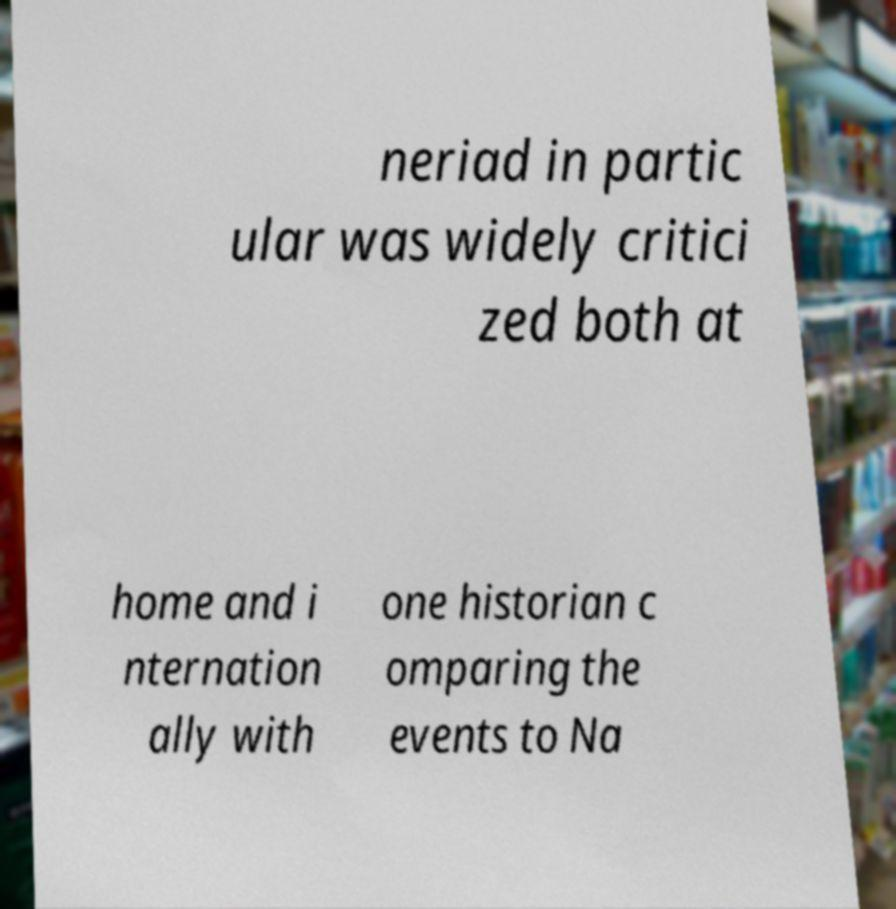Could you extract and type out the text from this image? neriad in partic ular was widely critici zed both at home and i nternation ally with one historian c omparing the events to Na 